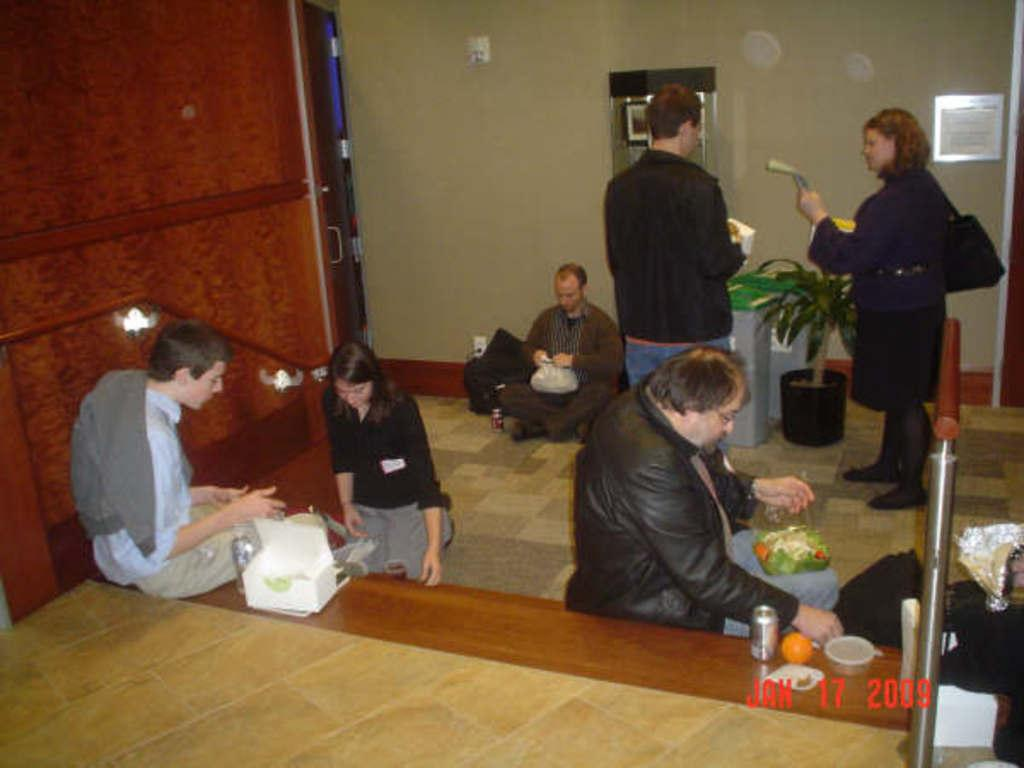How many people are seated in the image? There are three people seated on stairs in the image. What are the seated people doing? The seated people are having food. Are there any other people in the image besides the seated ones? Yes, there are two other people standing in front of the seated people. What are the standing people holding in their hands? The standing people are holding objects in their hands. What type of baseball equipment can be seen in the hands of the standing people? There is no baseball equipment present in the image. Is there a farmer in the image? There is no farmer present in the image. 